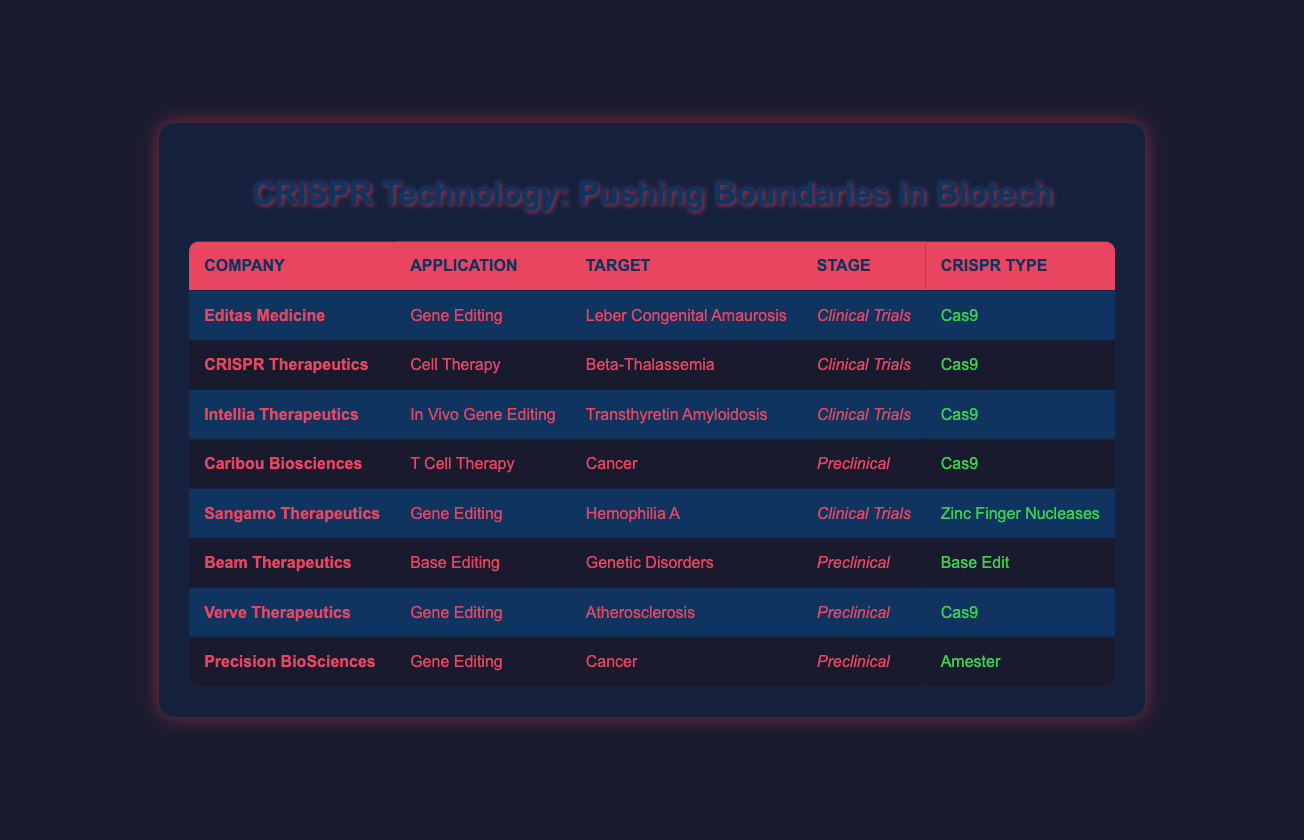What applications are listed for Editas Medicine? To find the application for Editas Medicine, locate the row for "Editas Medicine" and read the corresponding entry in the "Application" column, which is "Gene Editing."
Answer: Gene Editing How many companies are using Cas9 as their CRISPR type? The companies that use Cas9 are Editas Medicine, CRISPR Therapeutics, Intellia Therapeutics, Caribou Biosciences, Verve Therapeutics. Counting these gives a total of 5 companies.
Answer: 5 Is Sangamo Therapeutics in the clinical trials stage? Check the row for Sangamo Therapeutics and look at the "Stage" column. It states "Clinical Trials," confirming that Sangamo Therapeutics is indeed in that stage.
Answer: Yes Which company is focusing on base editing? Find the entry in the table for base editing by looking at the "Application" column. The company associated with base editing is "Beam Therapeutics."
Answer: Beam Therapeutics What is the average number of companies at clinical trials versus preclinical stages? Count the number of companies at "Clinical Trials" (Editas Medicine, CRISPR Therapeutics, Intellia Therapeutics, Sangamo Therapeutics) which totals 4, and for "Preclinical" (Caribou Biosciences, Beam Therapeutics, Verve Therapeutics, Precision BioSciences) which totals 4 as well. The average for both categories is 4/2 = 4.
Answer: 4 Are there any companies using Zinc Finger Nucleases in clinical trials? Look at the "CRISPR Type" for companies in the "Clinical Trials" stage. Sangamo Therapeutics uses Zinc Finger Nucleases in clinical trials.
Answer: Yes What is the target for the gene editing application by Verve Therapeutics? To find the target for Verve Therapeutics, find their row and look at the "Target" column, which states "Atherosclerosis."
Answer: Atherosclerosis How many companies target cancer using CRISPR technology? The companies targeting cancer are Caribou Biosciences and Precision BioSciences. So, there are 2 companies targeting cancer.
Answer: 2 What types of CRISPR technology are used by companies in preclinical stages? Review the "CRISPR Type" column for companies in "Preclinical" stage, which include Cas9 (Caribou Biosciences, Verve Therapeutics), Base Edit (Beam Therapeutics), and Amester (Precision BioSciences). This shows 3 different types of CRISPR technology in use.
Answer: 3 